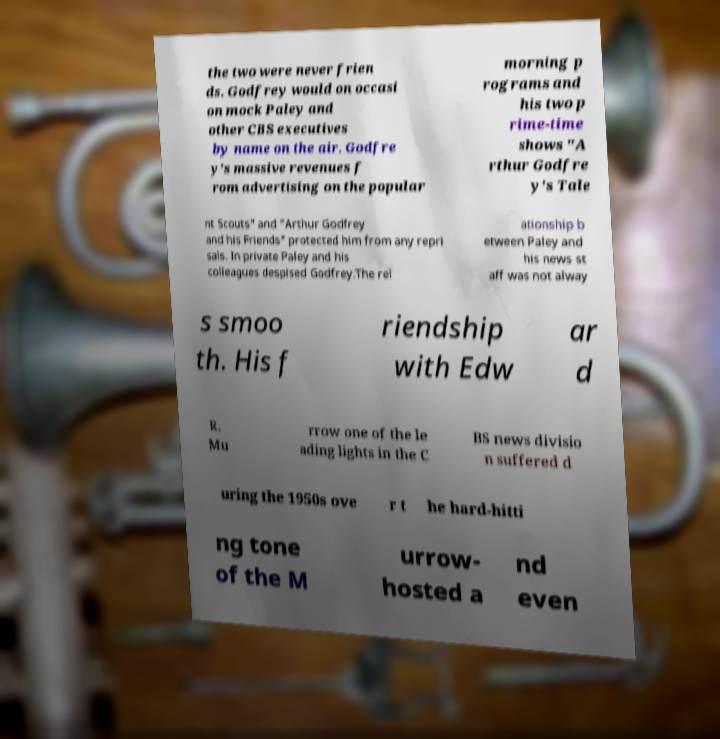Can you accurately transcribe the text from the provided image for me? the two were never frien ds. Godfrey would on occasi on mock Paley and other CBS executives by name on the air. Godfre y's massive revenues f rom advertising on the popular morning p rograms and his two p rime-time shows "A rthur Godfre y's Tale nt Scouts" and "Arthur Godfrey and his Friends" protected him from any repri sals. In private Paley and his colleagues despised Godfrey.The rel ationship b etween Paley and his news st aff was not alway s smoo th. His f riendship with Edw ar d R. Mu rrow one of the le ading lights in the C BS news divisio n suffered d uring the 1950s ove r t he hard-hitti ng tone of the M urrow- hosted a nd even 